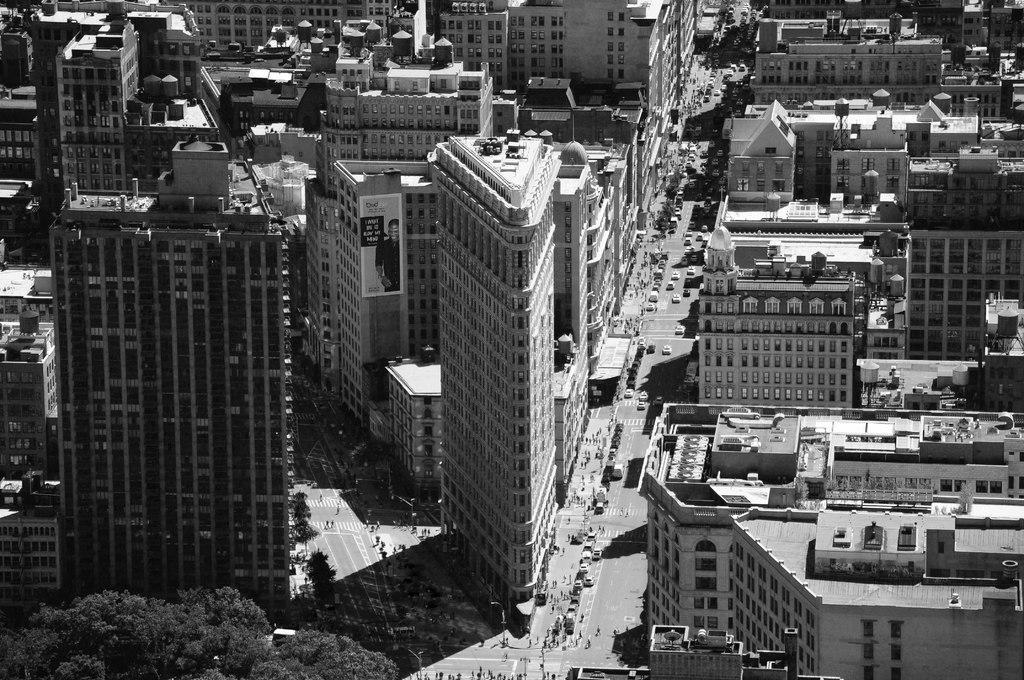What is the color scheme of the image? The image is black and white. What type of structures can be seen in the image? There are skyscrapers and buildings in the image. What is present on the road in the image? There are vehicles on the road in the image. What type of vegetation is visible in the image? There are trees visible in the image. How many screws are visible on the skyscrapers in the image? There are no screws visible on the skyscrapers in the image, as it is a black and white photograph and screws are not a prominent feature of skyscrapers. 